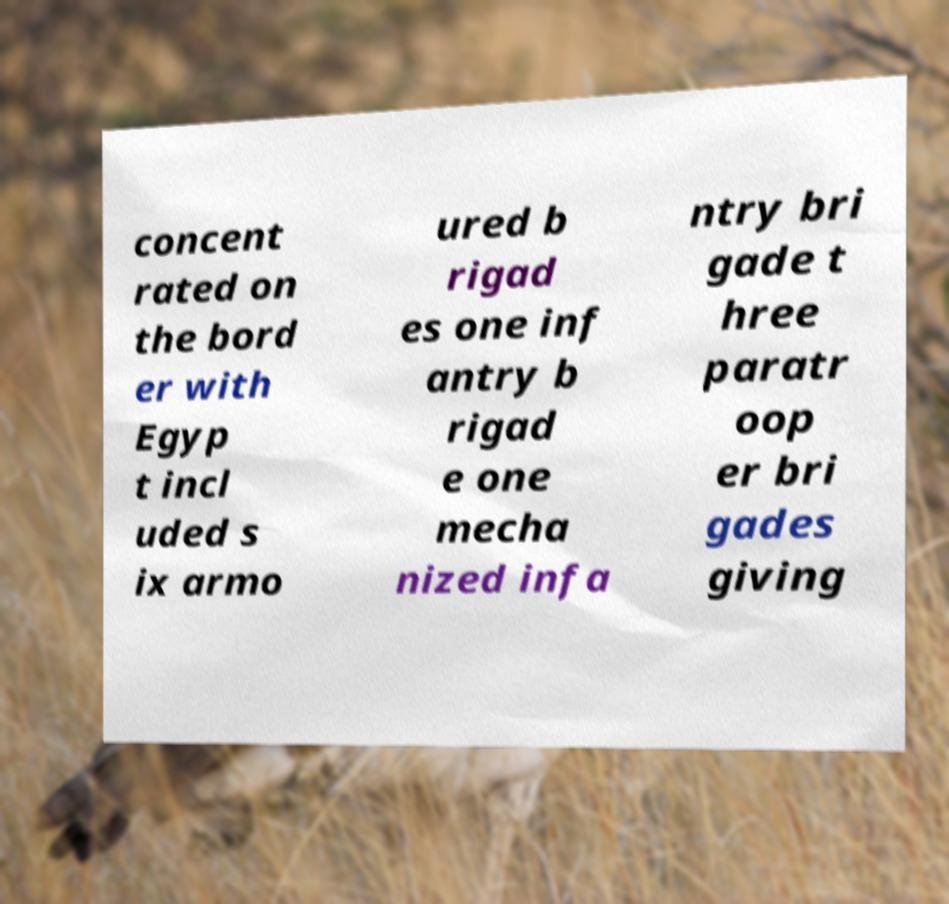Could you extract and type out the text from this image? concent rated on the bord er with Egyp t incl uded s ix armo ured b rigad es one inf antry b rigad e one mecha nized infa ntry bri gade t hree paratr oop er bri gades giving 